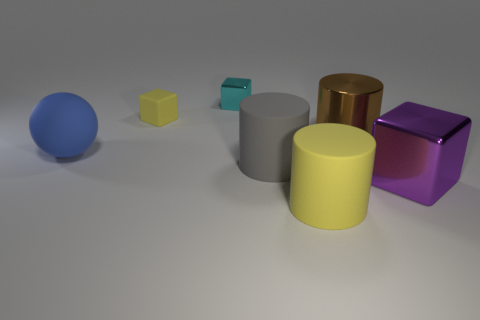Are there any other things that have the same color as the big sphere?
Ensure brevity in your answer.  No. How many shiny things are tiny purple cylinders or big yellow objects?
Your answer should be very brief. 0. Is the big shiny cube the same color as the tiny rubber block?
Provide a short and direct response. No. Are there more tiny cyan things that are left of the large rubber ball than yellow matte things?
Your answer should be very brief. No. How many other objects are the same material as the big yellow cylinder?
Provide a succinct answer. 3. How many small things are red objects or spheres?
Provide a short and direct response. 0. Do the large blue thing and the yellow cube have the same material?
Make the answer very short. Yes. There is a large blue rubber sphere to the left of the tiny yellow rubber object; how many large metal things are in front of it?
Your answer should be very brief. 1. Are there any yellow objects that have the same shape as the large blue matte object?
Offer a terse response. No. There is a matte thing in front of the gray rubber cylinder; is its shape the same as the yellow object that is left of the tiny metallic block?
Your answer should be compact. No. 